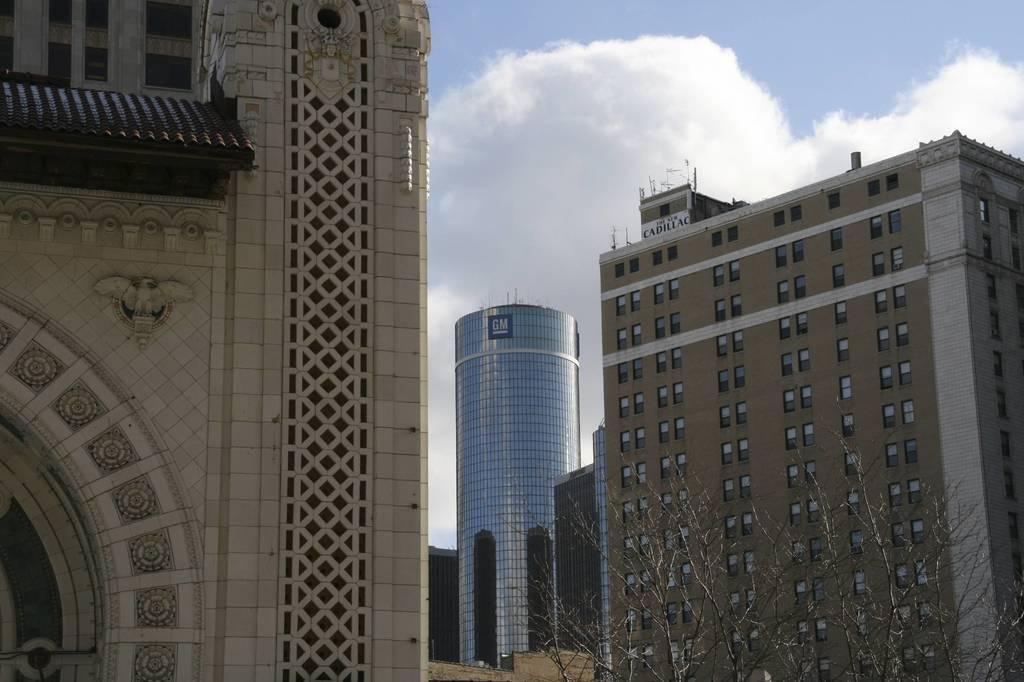Describe this image in one or two sentences. In this image there are buildings, in the background there is the sky, on the bottom right there is a tree. 